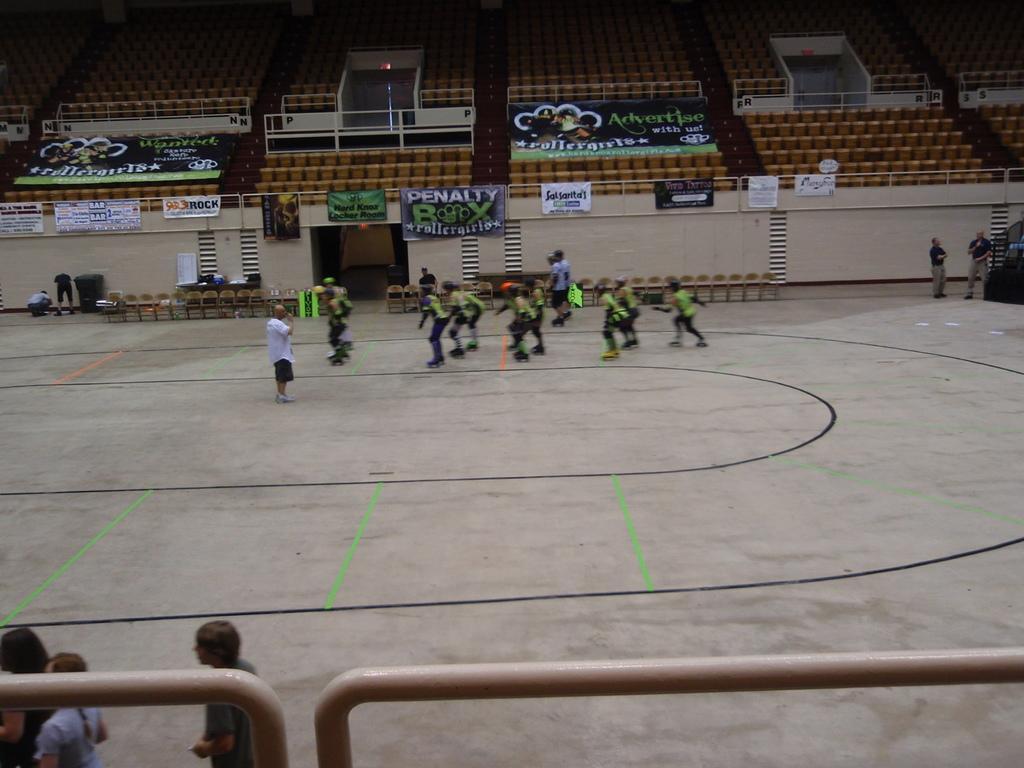Describe this image in one or two sentences. There is a ground. On the ground many people are skating with skate shoes. One person is standing. At the bottom there is a railing and few people. In the back there are chairs. Also there is a wall. And there are banners on the railing. In the background there are chairs. And there are banners. 